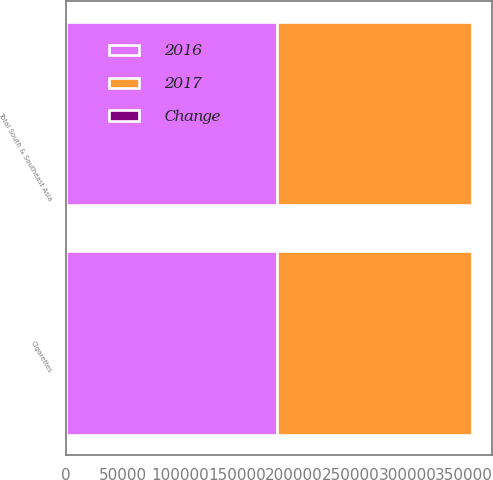Convert chart to OTSL. <chart><loc_0><loc_0><loc_500><loc_500><stacked_bar_chart><ecel><fcel>Cigarettes<fcel>Total South & Southeast Asia<nl><fcel>2017<fcel>171600<fcel>171600<nl><fcel>2016<fcel>185279<fcel>185279<nl><fcel>Change<fcel>7.4<fcel>7.4<nl></chart> 